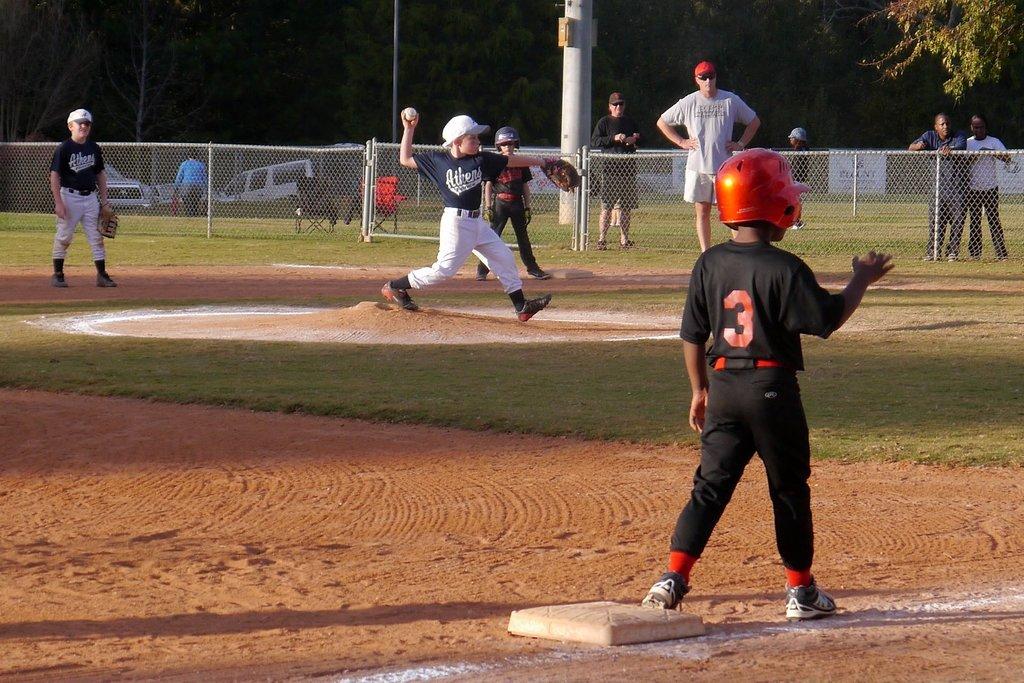What city is the pitcher from?
Give a very brief answer. Athens. 